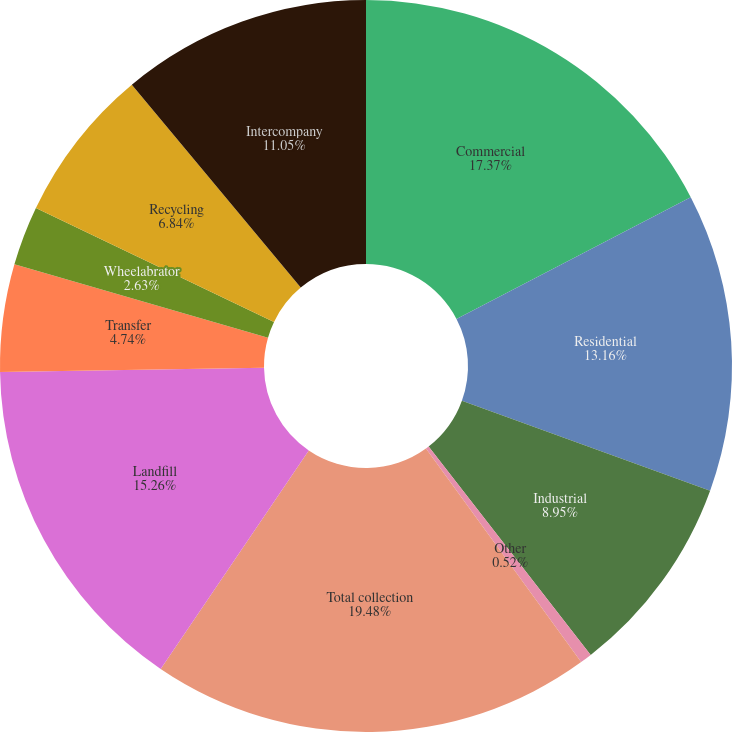Convert chart. <chart><loc_0><loc_0><loc_500><loc_500><pie_chart><fcel>Commercial<fcel>Residential<fcel>Industrial<fcel>Other<fcel>Total collection<fcel>Landfill<fcel>Transfer<fcel>Wheelabrator<fcel>Recycling<fcel>Intercompany<nl><fcel>17.37%<fcel>13.16%<fcel>8.95%<fcel>0.52%<fcel>19.48%<fcel>15.26%<fcel>4.74%<fcel>2.63%<fcel>6.84%<fcel>11.05%<nl></chart> 